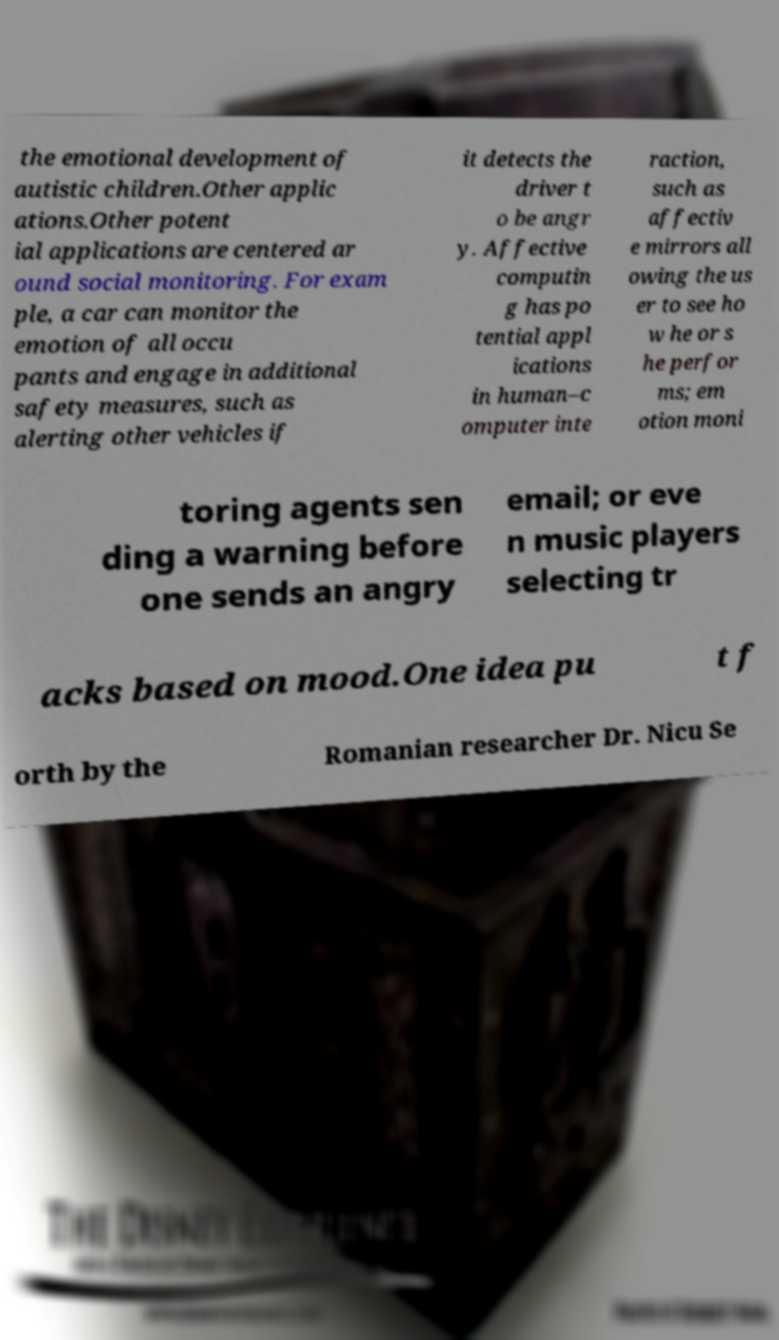I need the written content from this picture converted into text. Can you do that? the emotional development of autistic children.Other applic ations.Other potent ial applications are centered ar ound social monitoring. For exam ple, a car can monitor the emotion of all occu pants and engage in additional safety measures, such as alerting other vehicles if it detects the driver t o be angr y. Affective computin g has po tential appl ications in human–c omputer inte raction, such as affectiv e mirrors all owing the us er to see ho w he or s he perfor ms; em otion moni toring agents sen ding a warning before one sends an angry email; or eve n music players selecting tr acks based on mood.One idea pu t f orth by the Romanian researcher Dr. Nicu Se 